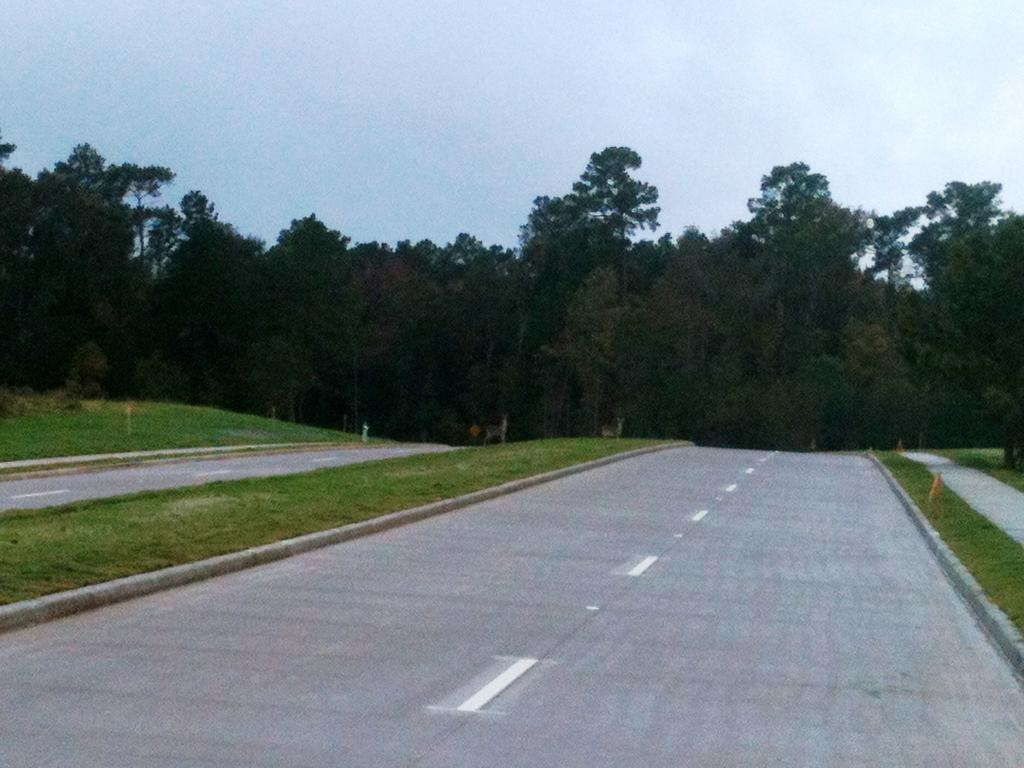What type of surface can be seen in the image? There is a road in the image. What type of vegetation is present in the image? There is grass and trees in the image. What color is the sky in the image? The sky is pale blue in the image. What hobbies are the trees participating in within the image? Trees do not have hobbies, as they are inanimate objects. What is the cause of the pale blue sky in the image? The cause of the pale blue sky in the image is not mentioned in the provided facts, but it could be due to the time of day or weather conditions. 